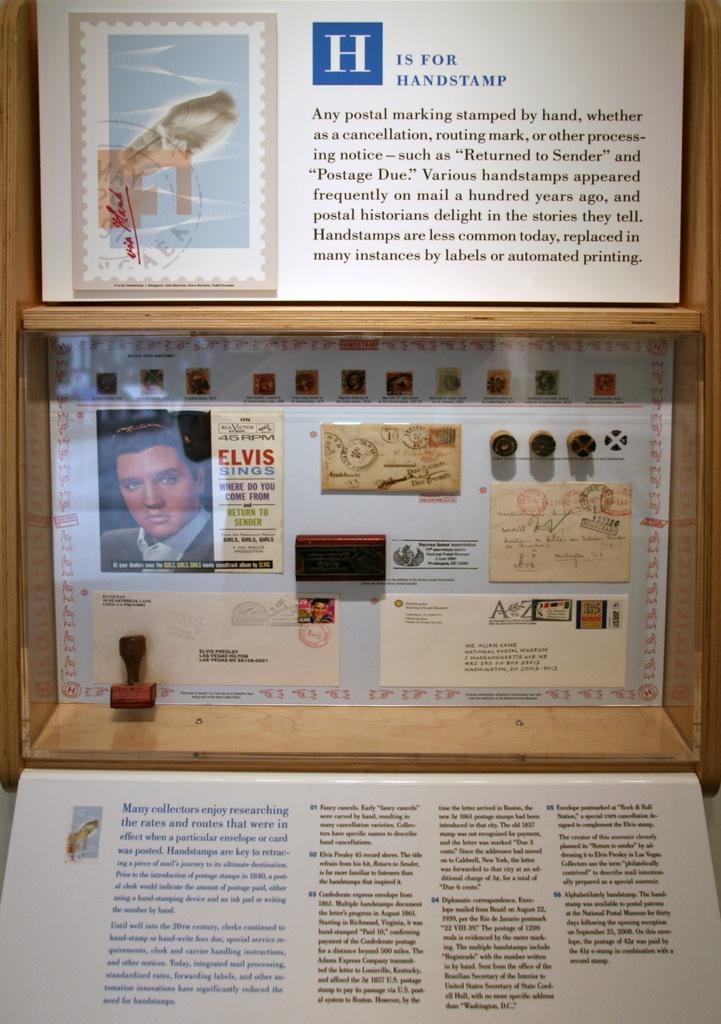<image>
Offer a succinct explanation of the picture presented. A display about postage with a picture of Elvis that says Elvis sings and under it has a list of his songs. 